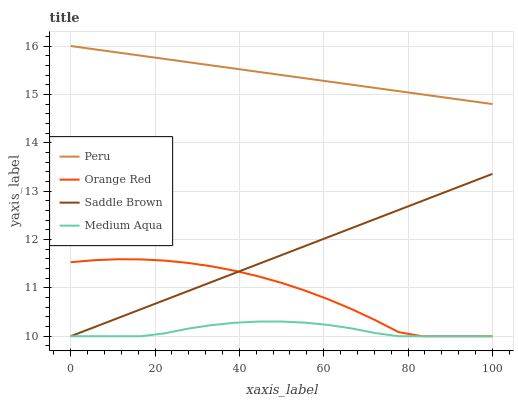Does Medium Aqua have the minimum area under the curve?
Answer yes or no. Yes. Does Peru have the maximum area under the curve?
Answer yes or no. Yes. Does Orange Red have the minimum area under the curve?
Answer yes or no. No. Does Orange Red have the maximum area under the curve?
Answer yes or no. No. Is Saddle Brown the smoothest?
Answer yes or no. Yes. Is Orange Red the roughest?
Answer yes or no. Yes. Is Peru the smoothest?
Answer yes or no. No. Is Peru the roughest?
Answer yes or no. No. Does Medium Aqua have the lowest value?
Answer yes or no. Yes. Does Peru have the lowest value?
Answer yes or no. No. Does Peru have the highest value?
Answer yes or no. Yes. Does Orange Red have the highest value?
Answer yes or no. No. Is Orange Red less than Peru?
Answer yes or no. Yes. Is Peru greater than Orange Red?
Answer yes or no. Yes. Does Medium Aqua intersect Orange Red?
Answer yes or no. Yes. Is Medium Aqua less than Orange Red?
Answer yes or no. No. Is Medium Aqua greater than Orange Red?
Answer yes or no. No. Does Orange Red intersect Peru?
Answer yes or no. No. 